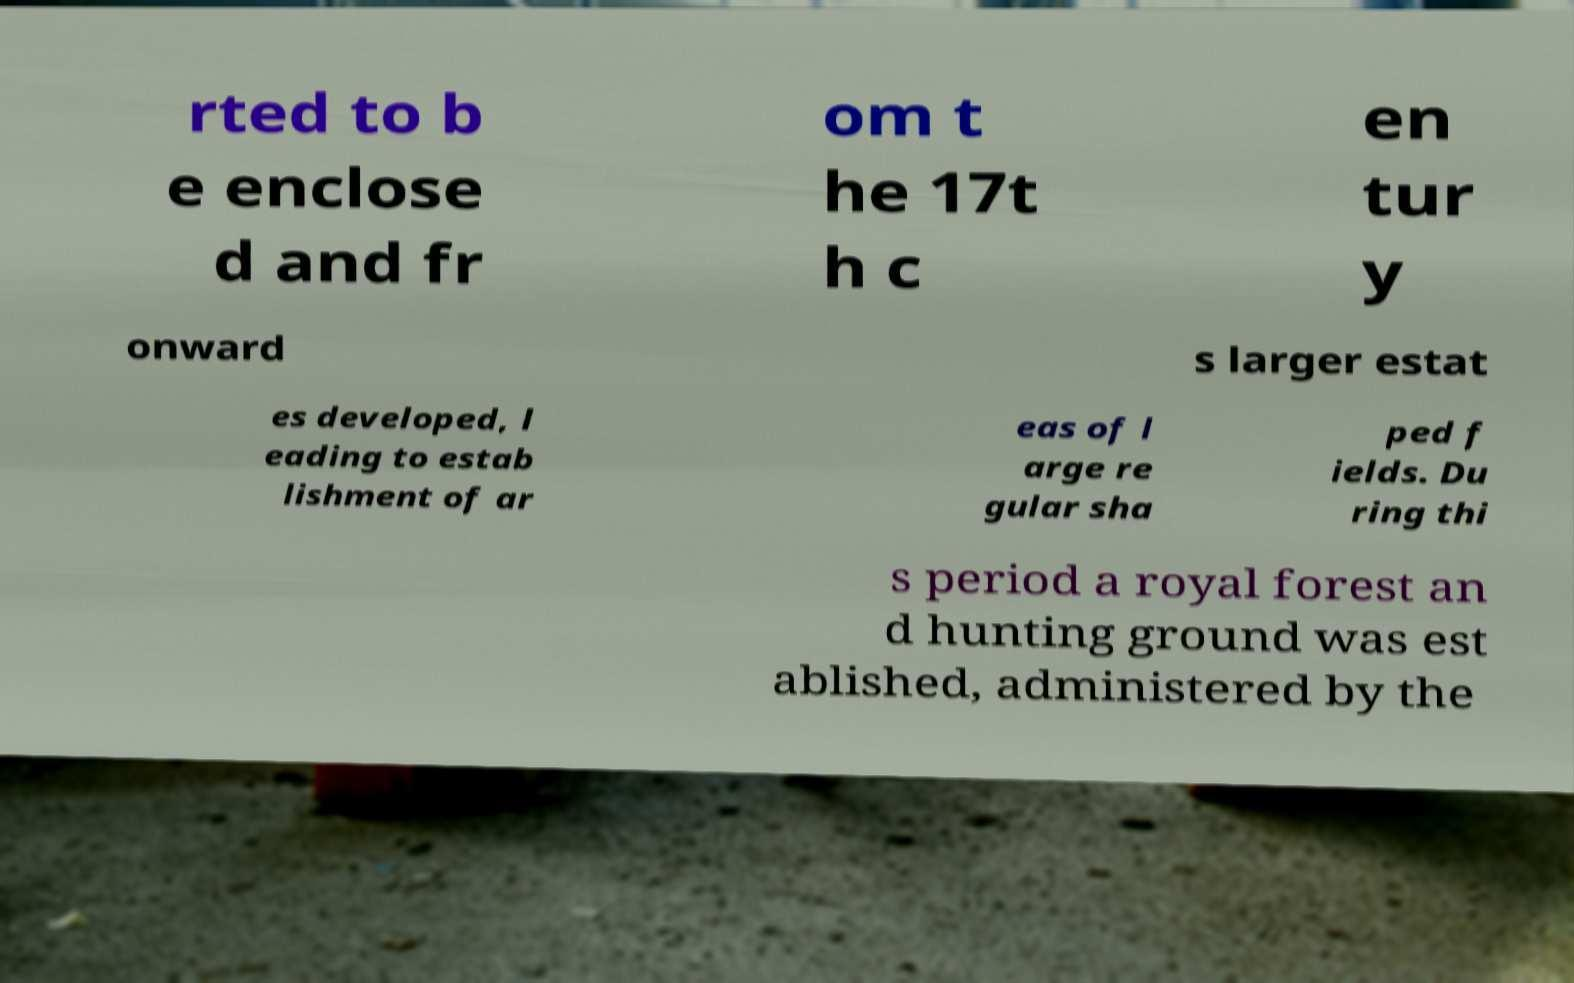There's text embedded in this image that I need extracted. Can you transcribe it verbatim? rted to b e enclose d and fr om t he 17t h c en tur y onward s larger estat es developed, l eading to estab lishment of ar eas of l arge re gular sha ped f ields. Du ring thi s period a royal forest an d hunting ground was est ablished, administered by the 